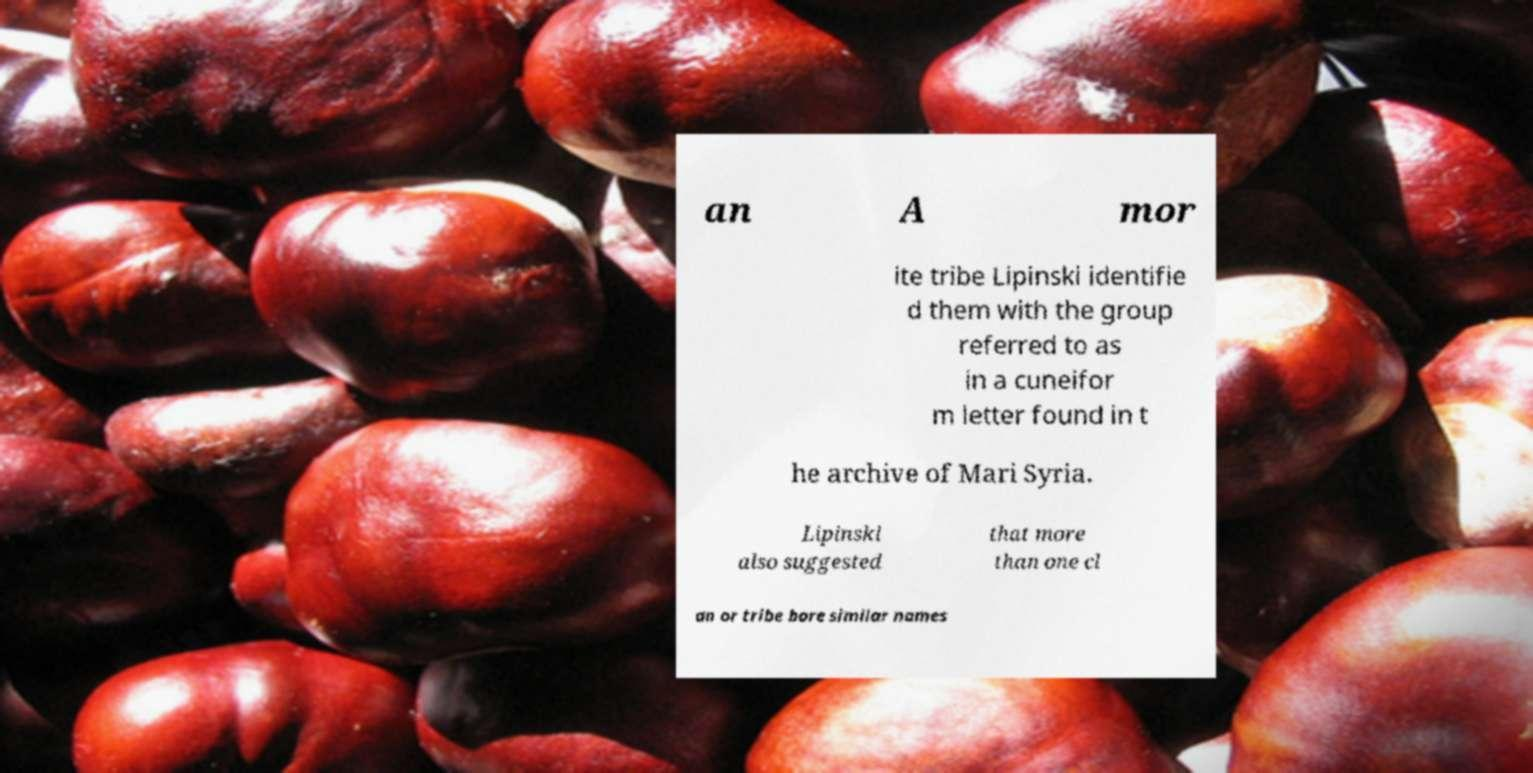For documentation purposes, I need the text within this image transcribed. Could you provide that? an A mor ite tribe Lipinski identifie d them with the group referred to as in a cuneifor m letter found in t he archive of Mari Syria. Lipinski also suggested that more than one cl an or tribe bore similar names 